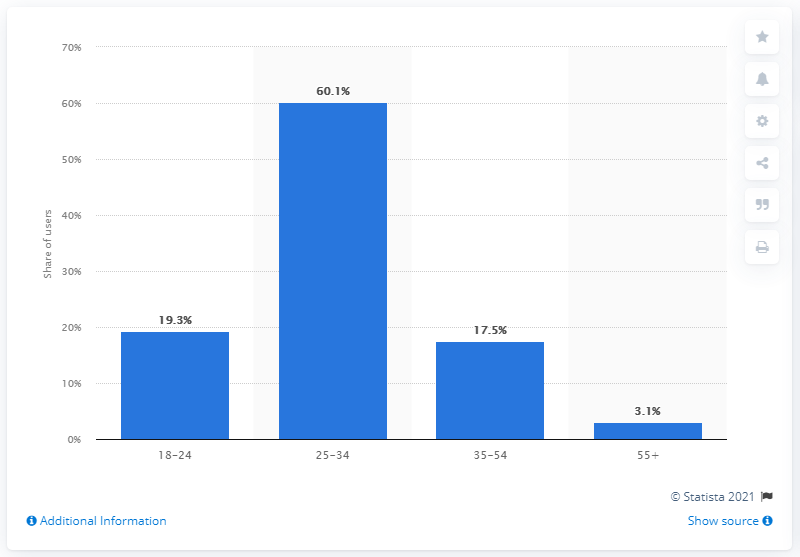Outline some significant characteristics in this image. During the survey period, 60.1% of global LinkedIn audiences were between 25 and 34 years old. 